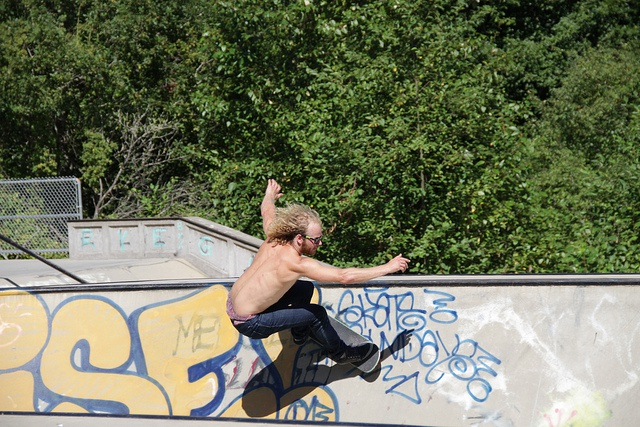Describe the objects in this image and their specific colors. I can see people in black, tan, and gray tones and skateboard in black and gray tones in this image. 